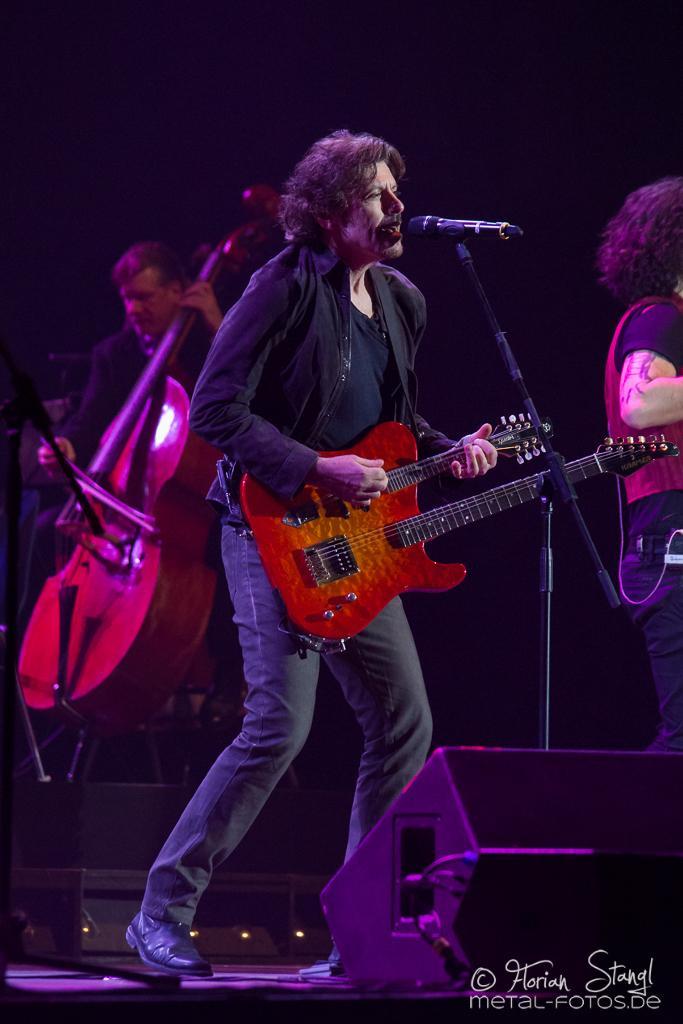In one or two sentences, can you explain what this image depicts? In this image we can see the people standing and playing the guitars. We can also see the miles with the stands. We can see some other objects. We can see the lights, stage and also the text. 